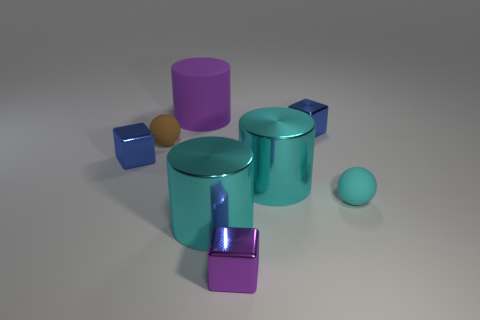What number of things are either tiny purple cubes or cyan shiny objects?
Make the answer very short. 3. Are there any purple things that have the same shape as the small brown thing?
Your response must be concise. No. There is a tiny shiny object to the left of the purple rubber thing; is it the same color as the matte cylinder?
Offer a very short reply. No. What shape is the purple thing that is in front of the tiny sphere that is to the left of the cyan sphere?
Ensure brevity in your answer.  Cube. Are there any red matte cylinders of the same size as the purple metallic object?
Ensure brevity in your answer.  No. Are there fewer big purple cylinders than red rubber things?
Give a very brief answer. No. What shape is the matte thing that is behind the blue shiny thing that is to the right of the purple metallic cube that is left of the cyan sphere?
Make the answer very short. Cylinder. What number of things are either cubes in front of the tiny cyan matte sphere or cyan things that are on the right side of the tiny purple metal cube?
Your answer should be very brief. 3. Are there any cyan matte objects behind the large purple object?
Keep it short and to the point. No. How many things are either spheres that are right of the big purple matte cylinder or big yellow metallic things?
Offer a very short reply. 1. 